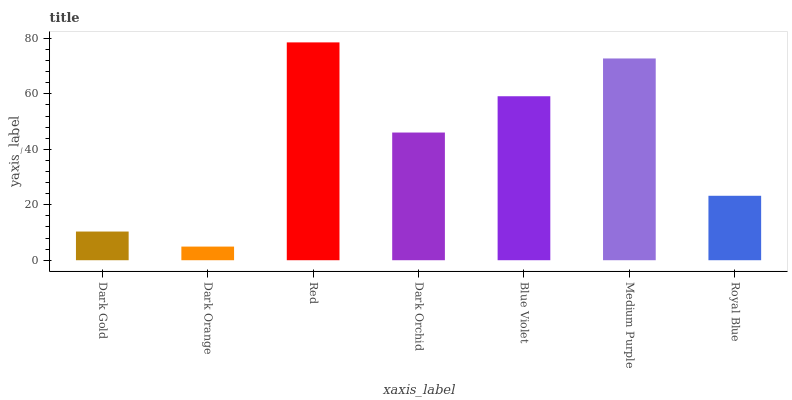Is Dark Orange the minimum?
Answer yes or no. Yes. Is Red the maximum?
Answer yes or no. Yes. Is Red the minimum?
Answer yes or no. No. Is Dark Orange the maximum?
Answer yes or no. No. Is Red greater than Dark Orange?
Answer yes or no. Yes. Is Dark Orange less than Red?
Answer yes or no. Yes. Is Dark Orange greater than Red?
Answer yes or no. No. Is Red less than Dark Orange?
Answer yes or no. No. Is Dark Orchid the high median?
Answer yes or no. Yes. Is Dark Orchid the low median?
Answer yes or no. Yes. Is Blue Violet the high median?
Answer yes or no. No. Is Blue Violet the low median?
Answer yes or no. No. 